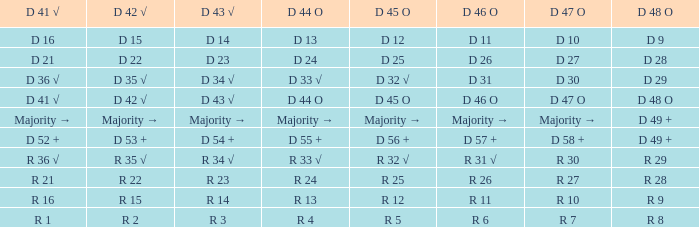Name the D 41 √ with D 44 O of r 13 R 16. 